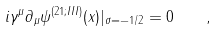<formula> <loc_0><loc_0><loc_500><loc_500>i \gamma ^ { \mu } \partial _ { \mu } \psi ^ { ( 2 1 ; I I I ) } ( x ) | _ { \sigma = - 1 / 2 } = 0 \quad ,</formula> 